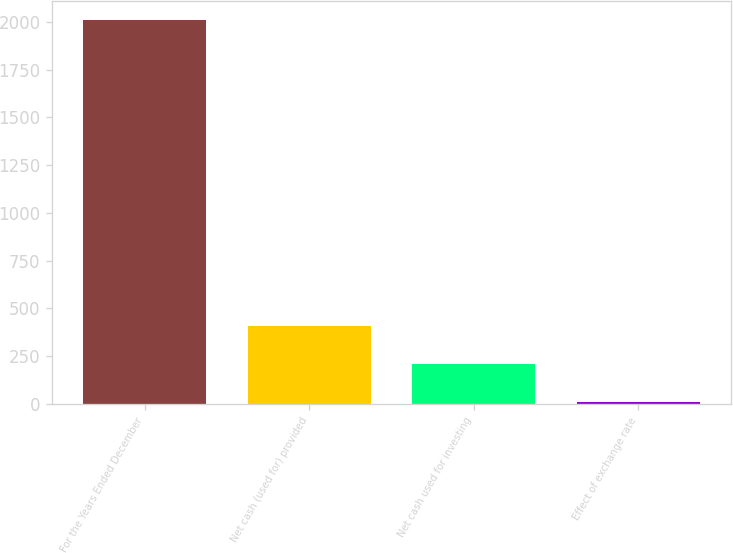Convert chart to OTSL. <chart><loc_0><loc_0><loc_500><loc_500><bar_chart><fcel>For the Years Ended December<fcel>Net cash (used for) provided<fcel>Net cash used for investing<fcel>Effect of exchange rate<nl><fcel>2008<fcel>408<fcel>208<fcel>8<nl></chart> 